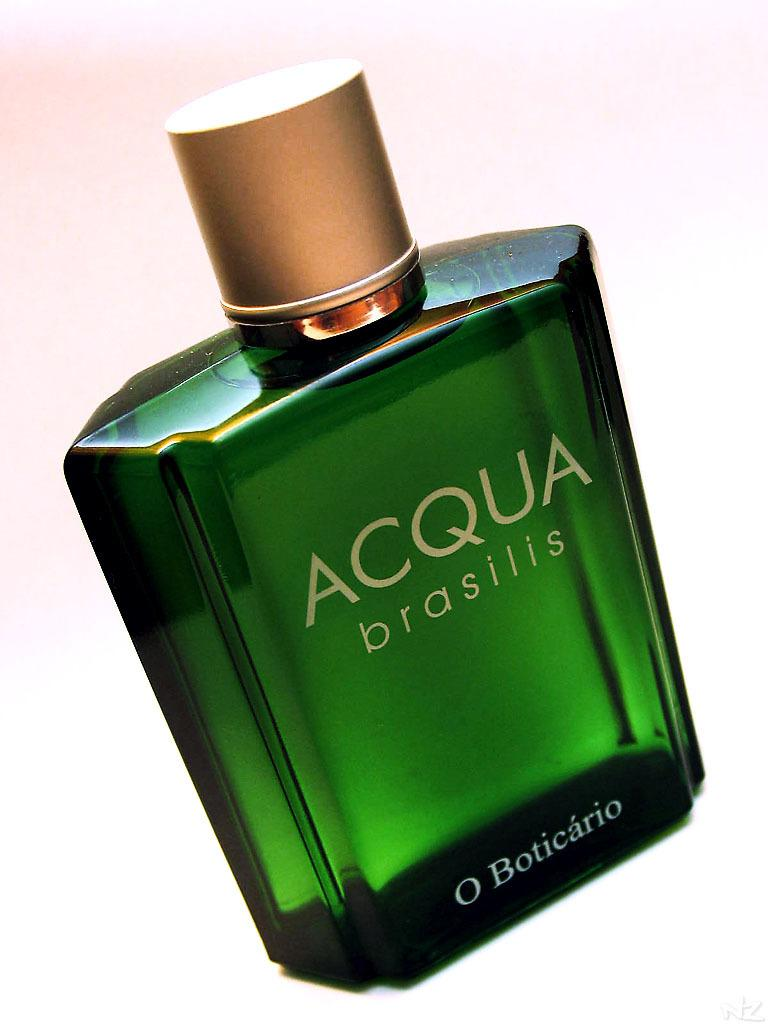<image>
Share a concise interpretation of the image provided. An Acqua Brasilis perfume bottle with green liquid. 